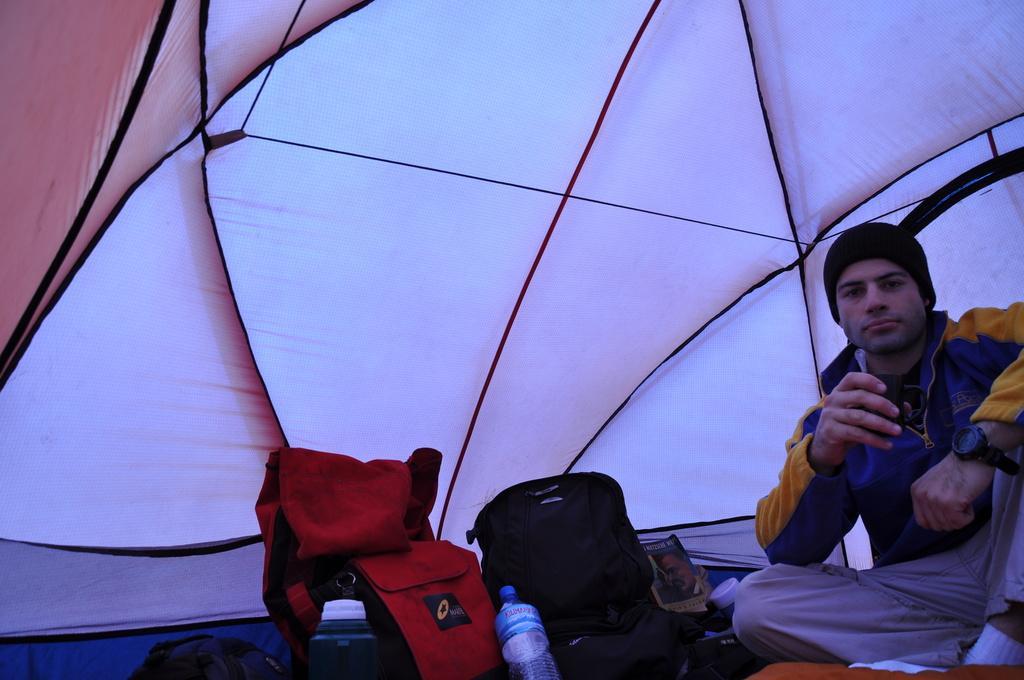How would you summarize this image in a sentence or two? In this picture we can see an inside view of a tent, on the right side there is a man sitting, we can see bags, a bottle and a book in the middle, this man is holding a cup. 